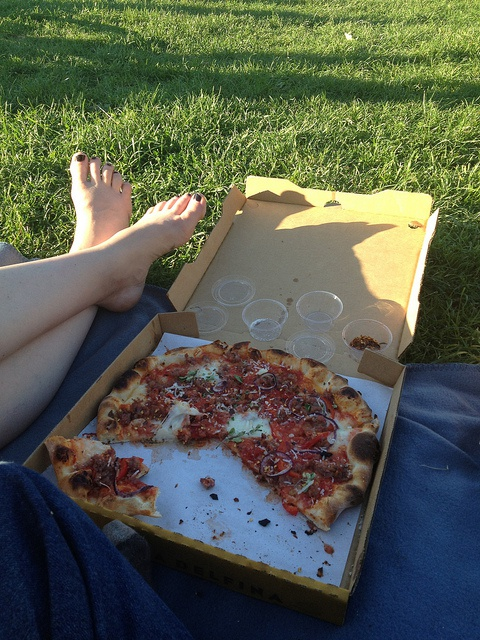Describe the objects in this image and their specific colors. I can see people in darkgreen, gray, black, and ivory tones, people in darkgreen, black, navy, and maroon tones, pizza in darkgreen, maroon, gray, black, and brown tones, pizza in darkgreen, maroon, black, gray, and brown tones, and pizza in darkgreen, maroon, black, and gray tones in this image. 